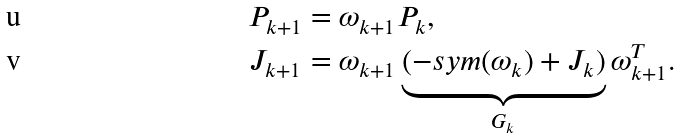<formula> <loc_0><loc_0><loc_500><loc_500>P _ { k + 1 } & = \omega _ { k + 1 } P _ { k } , \\ J _ { k + 1 } & = \omega _ { k + 1 } \underbrace { ( - s y m ( \omega _ { k } ) + J _ { k } ) } _ { G _ { k } } \omega _ { k + 1 } ^ { T } .</formula> 